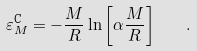Convert formula to latex. <formula><loc_0><loc_0><loc_500><loc_500>\varepsilon ^ { \text {C} } _ { M } = - \frac { M } { R } \ln { \left [ \alpha \frac { M } { R } \right ] } \quad .</formula> 